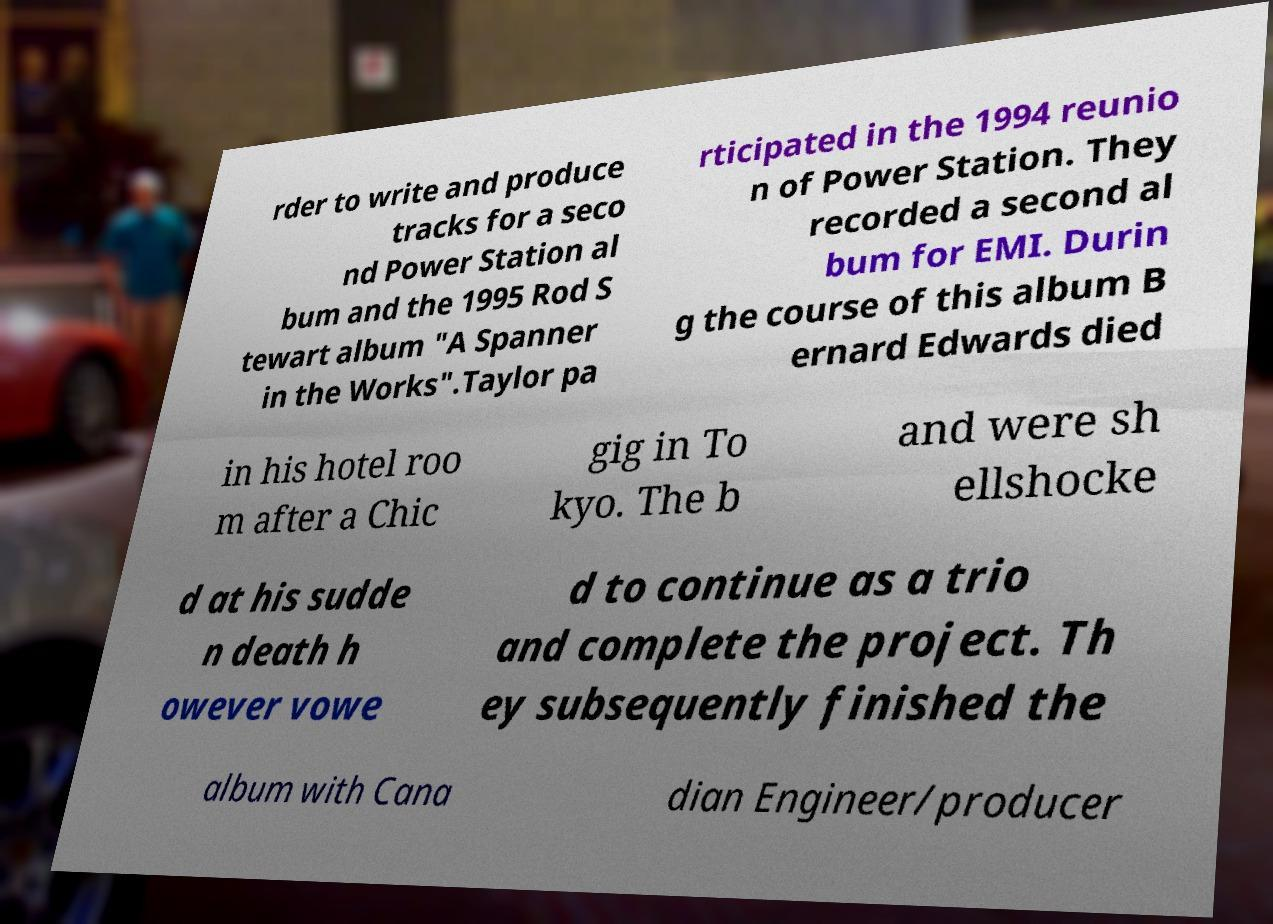Could you assist in decoding the text presented in this image and type it out clearly? rder to write and produce tracks for a seco nd Power Station al bum and the 1995 Rod S tewart album "A Spanner in the Works".Taylor pa rticipated in the 1994 reunio n of Power Station. They recorded a second al bum for EMI. Durin g the course of this album B ernard Edwards died in his hotel roo m after a Chic gig in To kyo. The b and were sh ellshocke d at his sudde n death h owever vowe d to continue as a trio and complete the project. Th ey subsequently finished the album with Cana dian Engineer/producer 